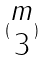Convert formula to latex. <formula><loc_0><loc_0><loc_500><loc_500>( \begin{matrix} m \\ 3 \end{matrix} )</formula> 